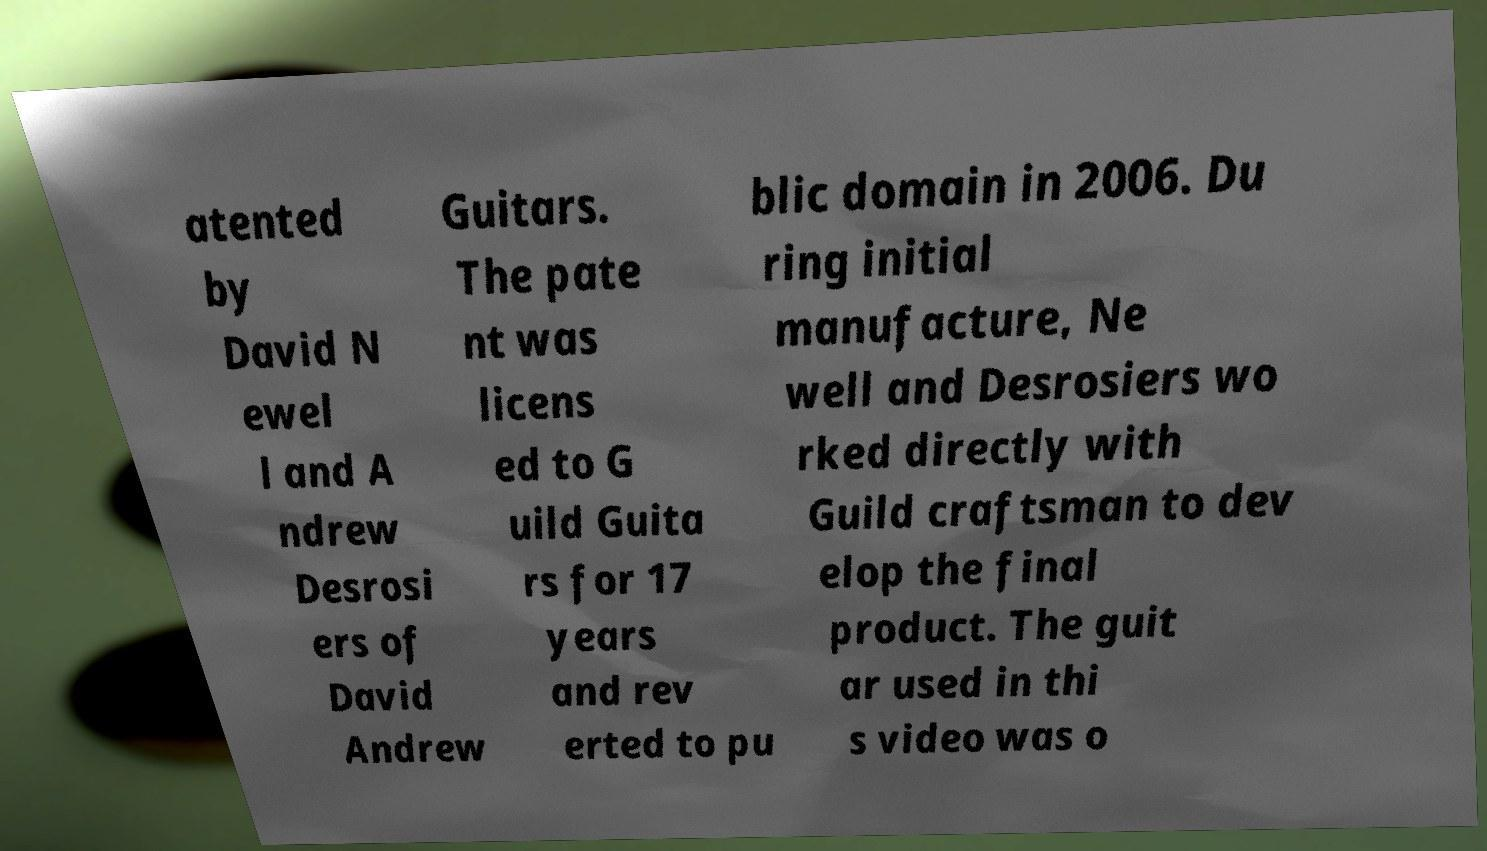For documentation purposes, I need the text within this image transcribed. Could you provide that? atented by David N ewel l and A ndrew Desrosi ers of David Andrew Guitars. The pate nt was licens ed to G uild Guita rs for 17 years and rev erted to pu blic domain in 2006. Du ring initial manufacture, Ne well and Desrosiers wo rked directly with Guild craftsman to dev elop the final product. The guit ar used in thi s video was o 